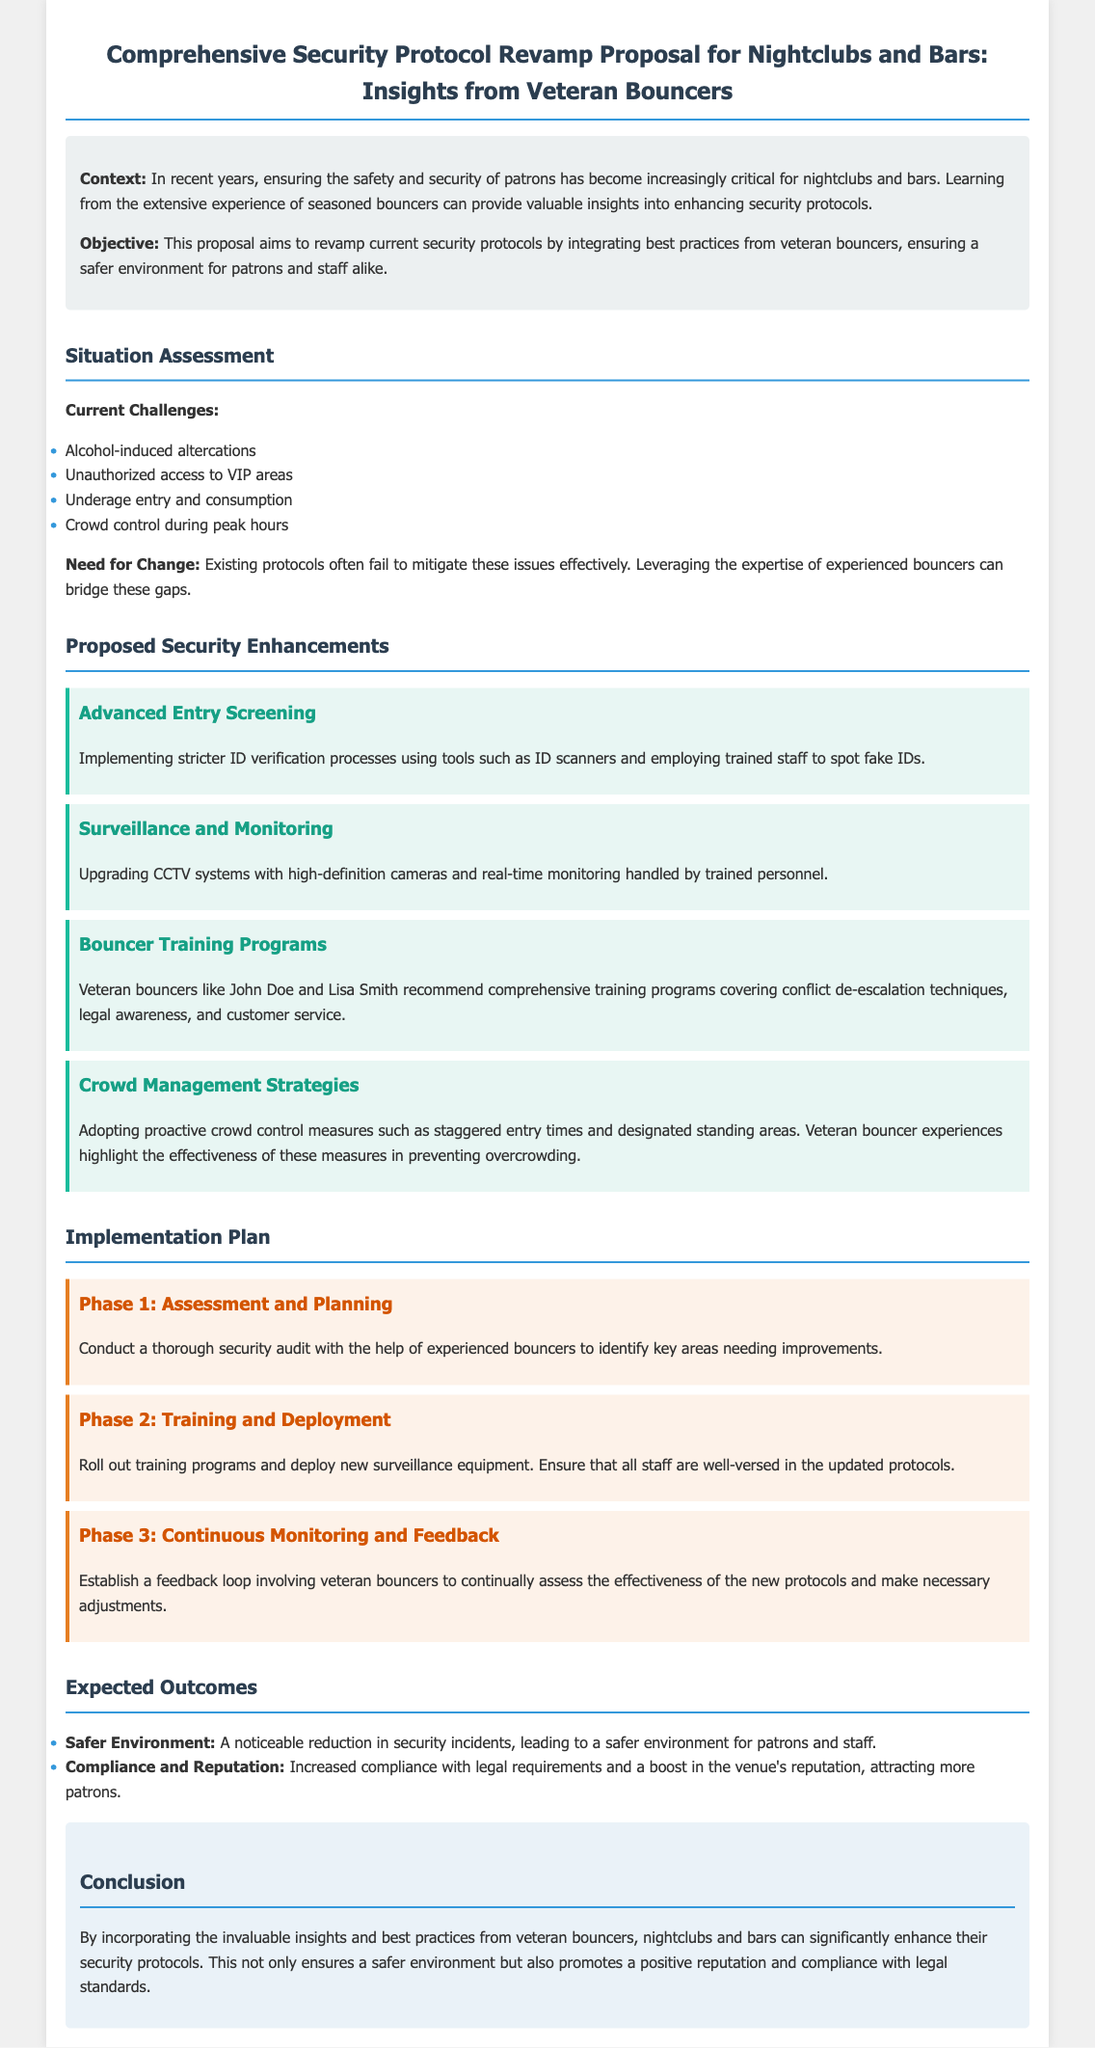what is the title of the proposal? The title of the proposal is presented prominently at the top of the document.
Answer: Comprehensive Security Protocol Revamp Proposal for Nightclubs and Bars: Insights from Veteran Bouncers what are the current challenges listed in the proposal? The current challenges are outlined in a specific section detailing issues faced by nightclubs and bars.
Answer: Alcohol-induced altercations, Unauthorized access to VIP areas, Underage entry and consumption, Crowd control during peak hours who recommended the bouncer training programs? The proposal mentions veterans who provide recommendations for training programs.
Answer: John Doe and Lisa Smith in which phase is the security audit conducted? The implementation plan is divided into phases that highlight various steps in the process.
Answer: Phase 1: Assessment and Planning what is one expected outcome of the proposed security enhancements? Expected outcomes are listed in the document, summarizing the benefits of the enhancements.
Answer: Safer Environment what is the background color of the enhancement sections? The proposal uses different colors for various sections to enhance readability.
Answer: Light blue how many phases are detailed in the implementation plan? The implementation plan includes a specific number of phases that guide the process.
Answer: Three phases 